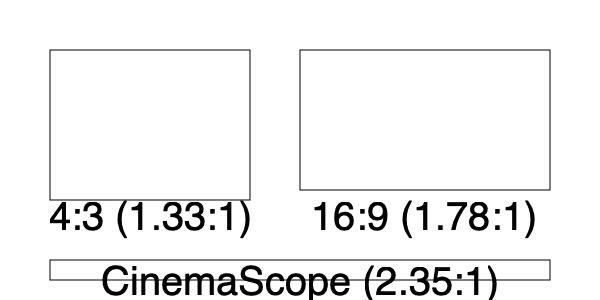As a film enthusiast in Washington, D.C., you've likely noticed changes in aspect ratios at local theaters like the AFI Silver Theatre. Which of these aspect ratios, illustrated above, was introduced first and revolutionized widescreen cinema in the 1950s? To answer this question, let's examine the evolution of aspect ratios in cinema:

1. 4:3 (1.33:1): This was the standard aspect ratio for early films and television. It was used from the silent film era through the early 1950s.

2. 16:9 (1.78:1): This aspect ratio became popular much later, in the 1990s and 2000s, primarily for high-definition television and digital video.

3. CinemaScope (2.35:1): This widescreen format was introduced by 20th Century Fox in 1953. It was the first successful widescreen format and revolutionized the film industry.

CinemaScope was developed as a response to the growing popularity of television in the 1950s. The wider screen provided a more immersive experience that couldn't be replicated on home TVs at the time.

The first CinemaScope film, "The Robe," premiered in 1953 and was a massive success. This led to widespread adoption of the format by other studios and theaters, including those in Washington, D.C.

While the exact 2.35:1 ratio has since been slightly modified (2.39:1 is now more common), the CinemaScope format was the pioneer of widescreen cinema and had a significant impact on the industry.
Answer: CinemaScope (2.35:1) 